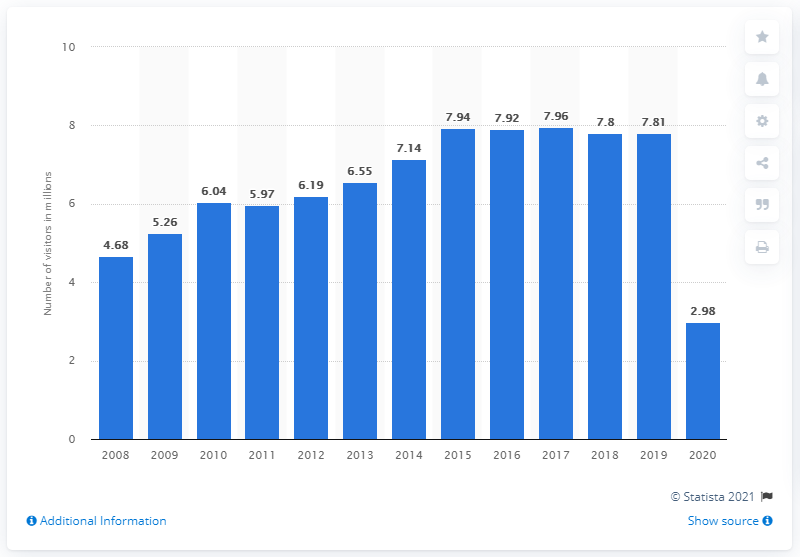Indicate a few pertinent items in this graphic. The COVID-19 containment measures at the Lincoln Memorial resulted in a reduction of visitors in 2020, with 2.98 million visitors affected. 